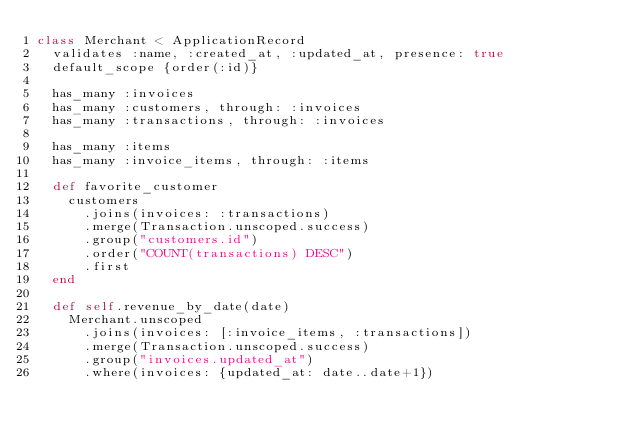<code> <loc_0><loc_0><loc_500><loc_500><_Ruby_>class Merchant < ApplicationRecord
  validates :name, :created_at, :updated_at, presence: true
  default_scope {order(:id)}

  has_many :invoices
  has_many :customers, through: :invoices
  has_many :transactions, through: :invoices

  has_many :items
  has_many :invoice_items, through: :items

  def favorite_customer
    customers
      .joins(invoices: :transactions)
      .merge(Transaction.unscoped.success)
      .group("customers.id")
      .order("COUNT(transactions) DESC")
      .first
  end

  def self.revenue_by_date(date)
    Merchant.unscoped
      .joins(invoices: [:invoice_items, :transactions])
      .merge(Transaction.unscoped.success)
      .group("invoices.updated_at")
      .where(invoices: {updated_at: date..date+1})</code> 